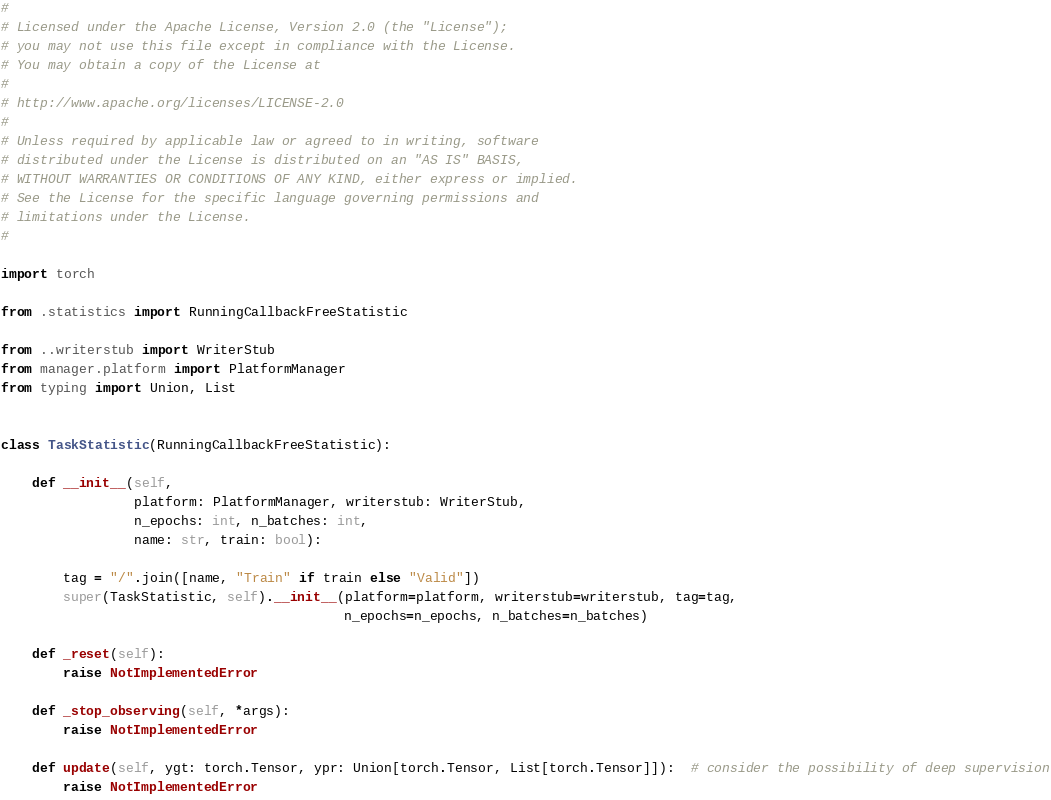Convert code to text. <code><loc_0><loc_0><loc_500><loc_500><_Python_># 
# Licensed under the Apache License, Version 2.0 (the "License");
# you may not use this file except in compliance with the License.
# You may obtain a copy of the License at
# 
# http://www.apache.org/licenses/LICENSE-2.0
# 
# Unless required by applicable law or agreed to in writing, software
# distributed under the License is distributed on an "AS IS" BASIS,
# WITHOUT WARRANTIES OR CONDITIONS OF ANY KIND, either express or implied.
# See the License for the specific language governing permissions and
# limitations under the License.
# 

import torch

from .statistics import RunningCallbackFreeStatistic

from ..writerstub import WriterStub
from manager.platform import PlatformManager
from typing import Union, List


class TaskStatistic(RunningCallbackFreeStatistic):

    def __init__(self,
                 platform: PlatformManager, writerstub: WriterStub,
                 n_epochs: int, n_batches: int,
                 name: str, train: bool):

        tag = "/".join([name, "Train" if train else "Valid"])
        super(TaskStatistic, self).__init__(platform=platform, writerstub=writerstub, tag=tag,
                                            n_epochs=n_epochs, n_batches=n_batches)

    def _reset(self):
        raise NotImplementedError

    def _stop_observing(self, *args):
        raise NotImplementedError

    def update(self, ygt: torch.Tensor, ypr: Union[torch.Tensor, List[torch.Tensor]]):  # consider the possibility of deep supervision
        raise NotImplementedError

</code> 